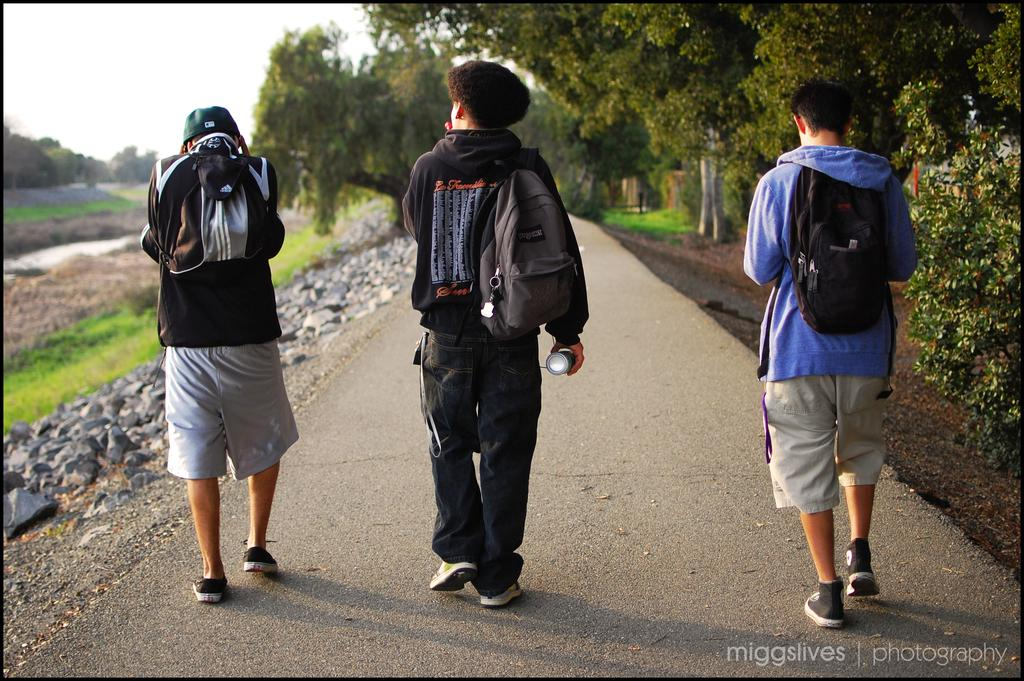What is happening in the image involving a group of people? There is a group of people in the image, and they are walking on the road. What are the people carrying while walking on the road? The people are wearing bags. What can be seen in the background of the image? There are trees and the sky visible in the image. What type of house can be seen in the image? There is no house present in the image. What reason do the people have for walking on the road in the image? The image does not provide information about the reason for the people walking on the road. 